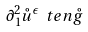Convert formula to latex. <formula><loc_0><loc_0><loc_500><loc_500>\partial _ { 1 } ^ { 2 } \mathring { u } ^ { \epsilon } \ t e n \mathring { g }</formula> 